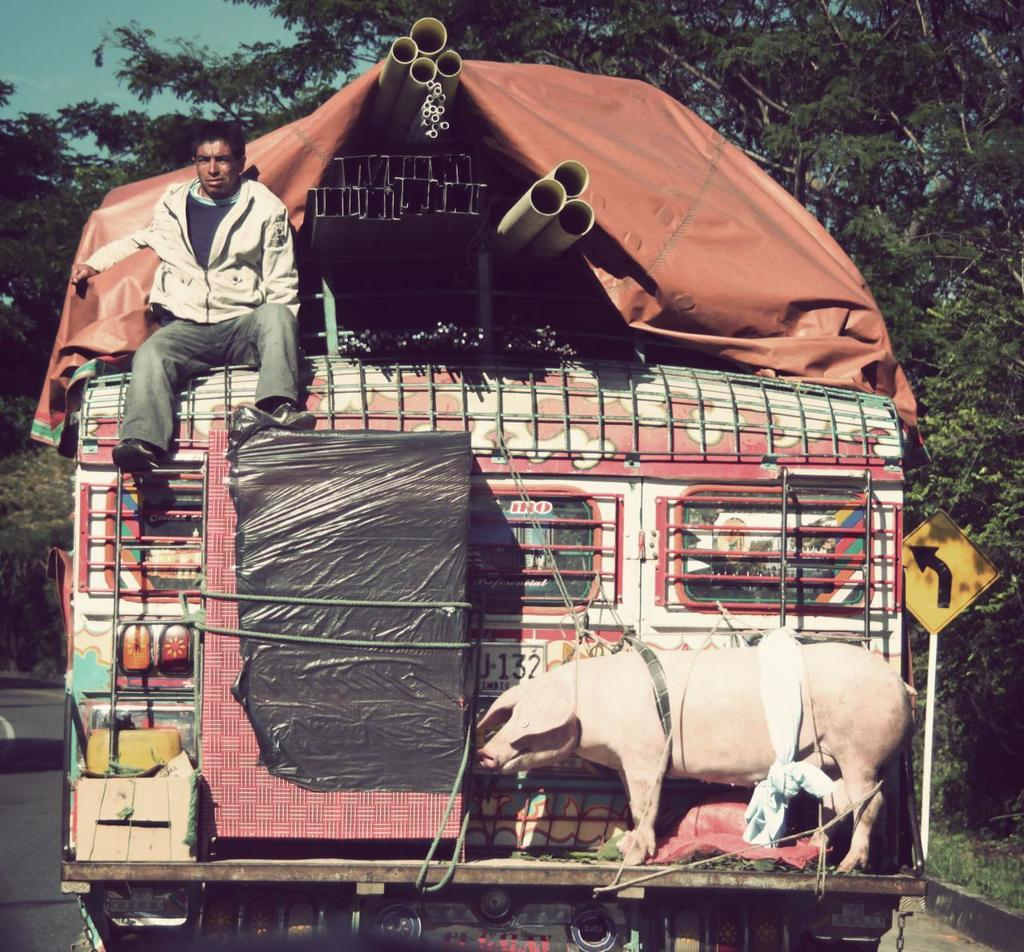What is the person in the image doing? There is a person sitting in the truck. What can be said about the truck's contents? The truck is fully loaded. What time of day is it in the image, considering the presence of the moon? There is no moon visible in the image, so it cannot be determined what time of day it is based on the presence of the moon. 